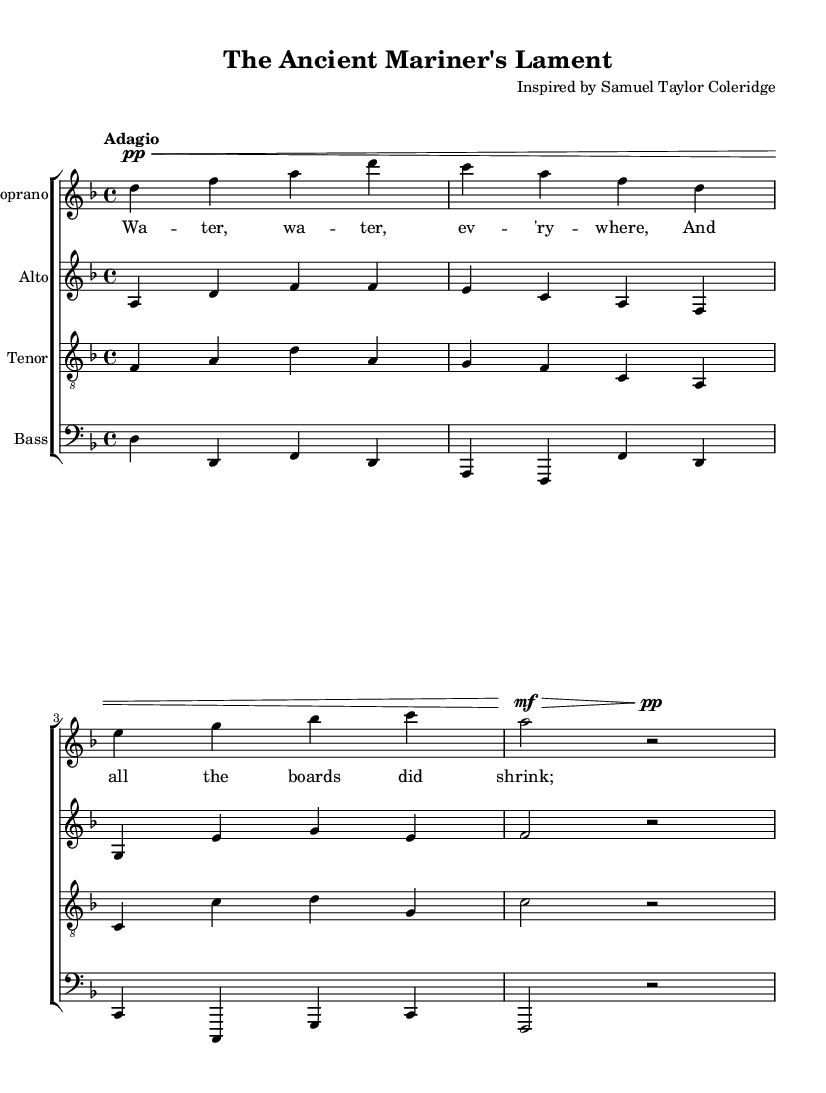What is the key signature of this music? The key signature is indicated at the beginning of the piece and shows one flat, which corresponds to D minor.
Answer: D minor What is the time signature of this piece? The time signature is found in the first measure, indicating how many beats are in a measure. Here, the time signature is 4/4, which means there are four beats per measure.
Answer: 4/4 What is the tempo indication for this piece? The tempo marking is located at the beginning of the score and specifies how fast the piece should be played. The marking "Adagio" indicates a slow tempo.
Answer: Adagio How many vocal parts are included in this score? By examining the score structure, there are four distinct staves, each representing a vocal part: soprano, alto, tenor, and bass, which means there are four vocal parts.
Answer: Four What is the title of this choral work? The title of the work is provided in the header section of the score, stating "The Ancient Mariner's Lament." The composer is also noted, but the question specifically asks for the title.
Answer: The Ancient Mariner's Lament Which literary figure inspired this composition? The header section of the score indicates the inspiration for the piece is drawn from a work by Samuel Taylor Coleridge, known for his poetic style from the Romantic era.
Answer: Samuel Taylor Coleridge What theme does the lyric reflect in this choral work? Analyzing the provided lyrics, they reflect a sense of despair about a lack of water, which evokes a vivid image related to Coleridge's poem "The Rime of the Ancient Mariner."
Answer: Lack of water 